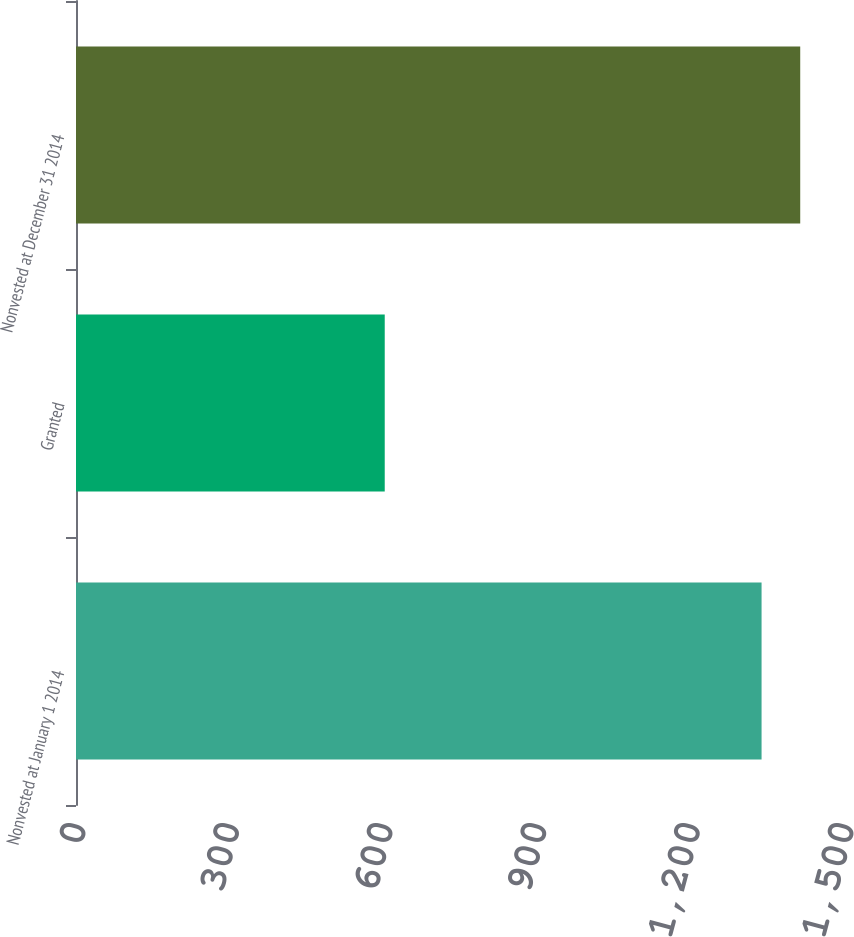Convert chart to OTSL. <chart><loc_0><loc_0><loc_500><loc_500><bar_chart><fcel>Nonvested at January 1 2014<fcel>Granted<fcel>Nonvested at December 31 2014<nl><fcel>1339<fcel>603<fcel>1414.5<nl></chart> 